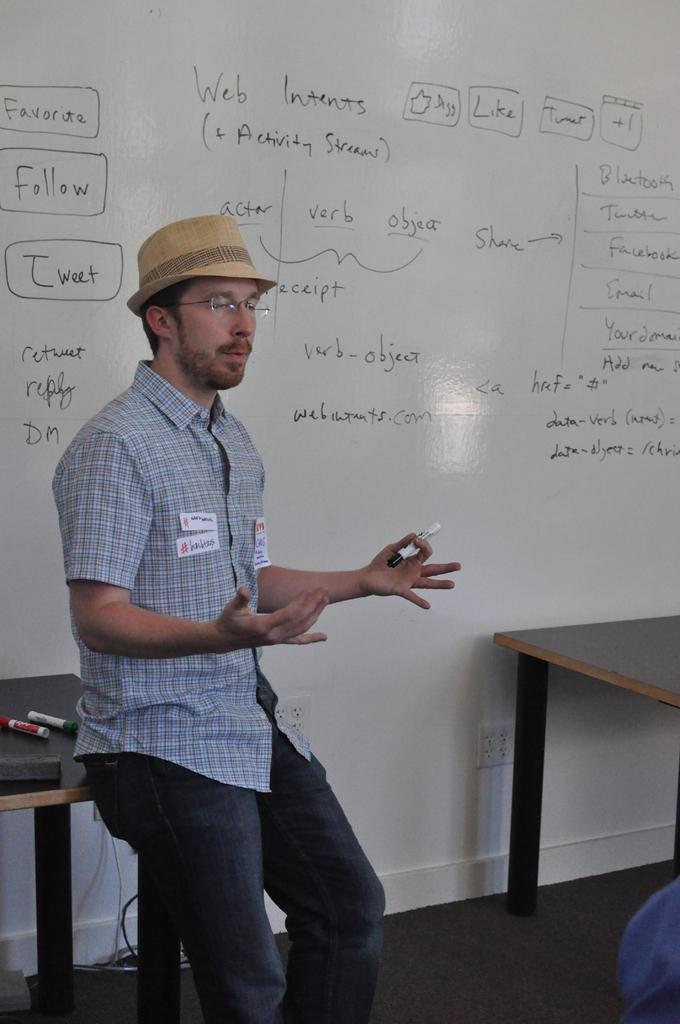<image>
Summarize the visual content of the image. favorite follow and tweet are mentioned on the white board behind the man 